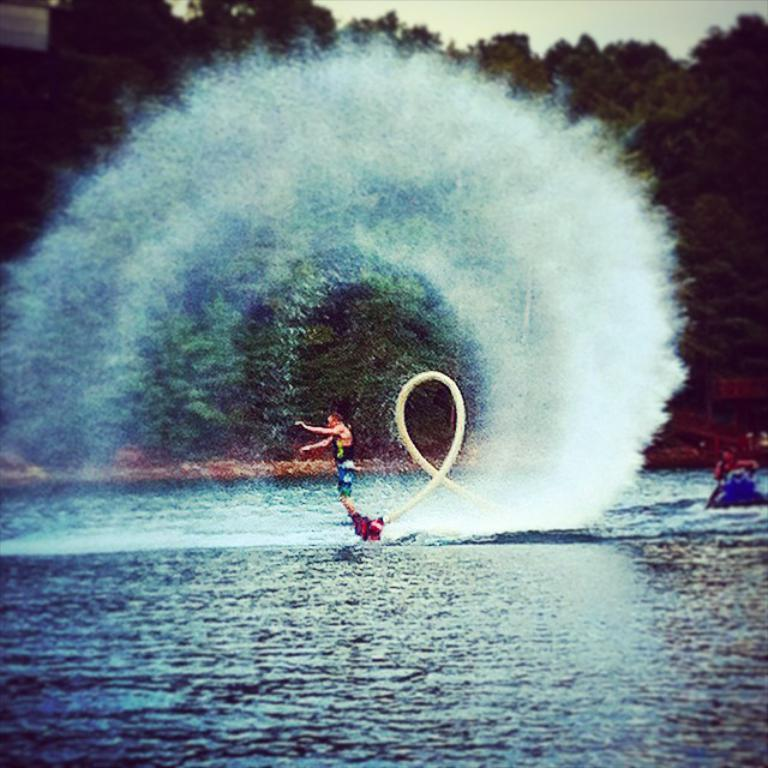What activity is the person on the jet ski engaged in? The person on the jet ski is engaged in water sports or recreational activity. What is the other person doing in the image? The other person is in a boat steamer. What can be seen in the background of the image? There are trees in the background of the image. What is visible in the foreground of the image? There is water visible in the foreground of the image. What type of pies is the person on the jet ski eating in the image? There is no indication in the image that the person on the jet ski is eating any pies. 